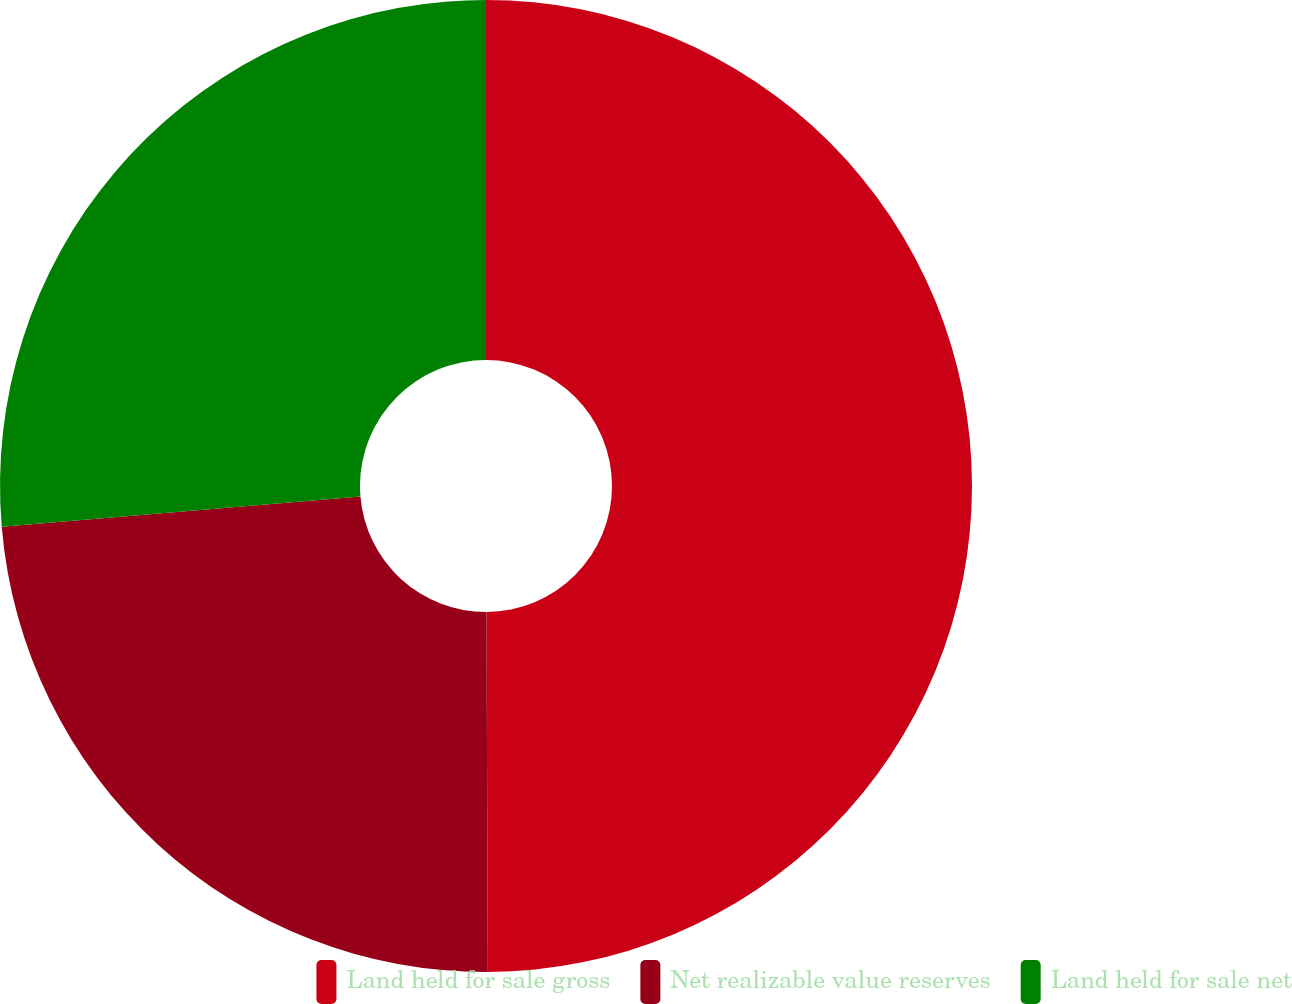Convert chart to OTSL. <chart><loc_0><loc_0><loc_500><loc_500><pie_chart><fcel>Land held for sale gross<fcel>Net realizable value reserves<fcel>Land held for sale net<nl><fcel>49.94%<fcel>23.72%<fcel>26.34%<nl></chart> 